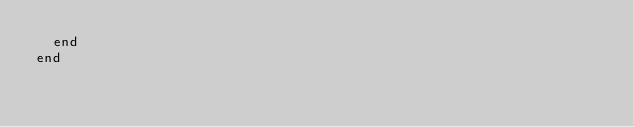<code> <loc_0><loc_0><loc_500><loc_500><_Ruby_>  end
end</code> 